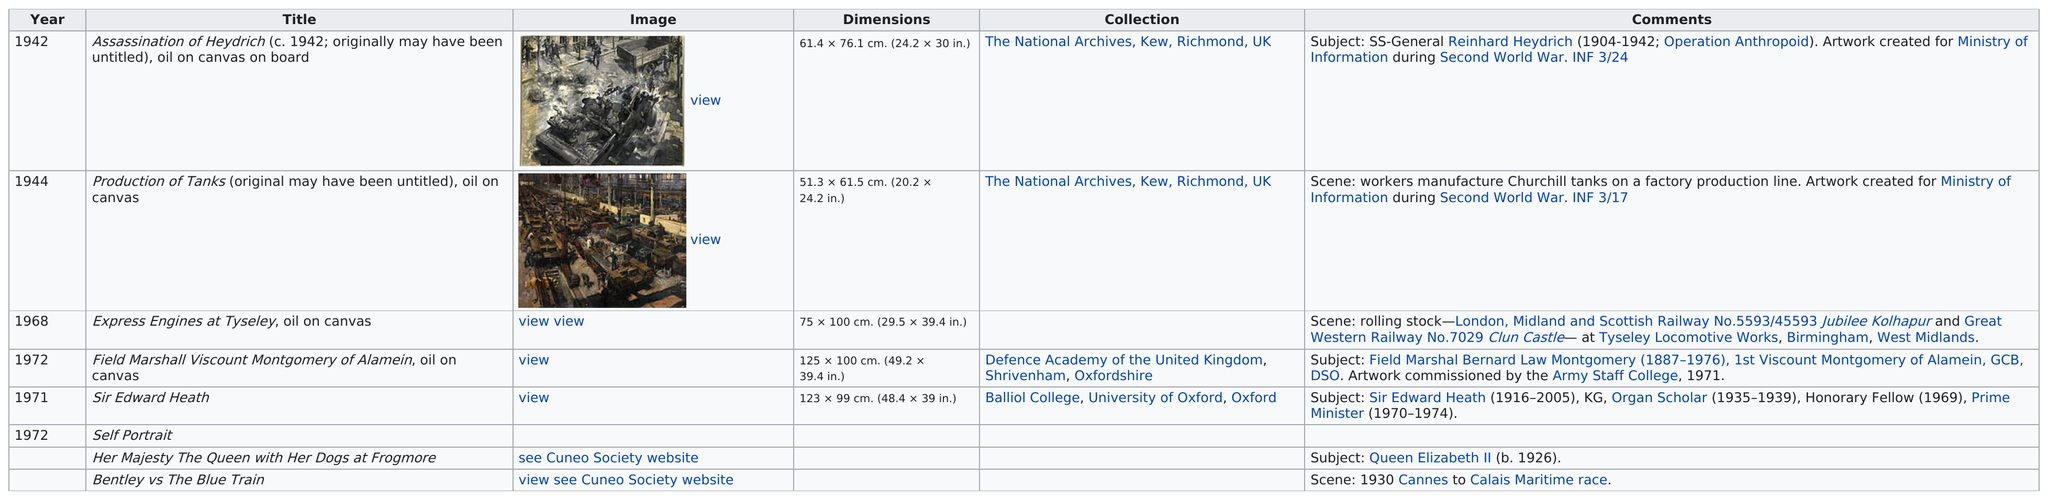Highlight a few significant elements in this photo. Terence Cuneo had completed two works before the year 1950. After the production of tanks, Express Engines at Tyseley, an oil on canvas piece of artwork, was released. Other than the assassination of Heydrich, the Ministry of Information produced various artworks, including the creation of tanks for production. Other than Field Marshal Viscount Montgomery of Alamein, can you name a piece that is more than 40 inches wide? Sir Edward Heath. Terence Cuneo's first work was called "The Assassination of Heydrich," a painting created in approximately 1942. Originally, the work may have been untitled. The painting is composed of oil on canvas on board. 